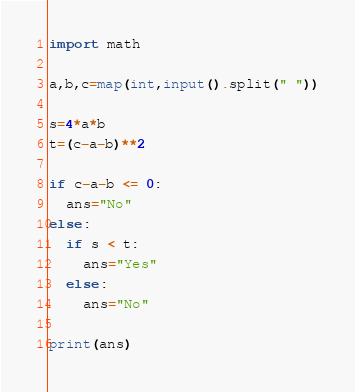<code> <loc_0><loc_0><loc_500><loc_500><_Python_>import math

a,b,c=map(int,input().split(" "))

s=4*a*b
t=(c-a-b)**2

if c-a-b <= 0:
  ans="No"
else:
  if s < t:
    ans="Yes"
  else:
    ans="No"

print(ans)
</code> 